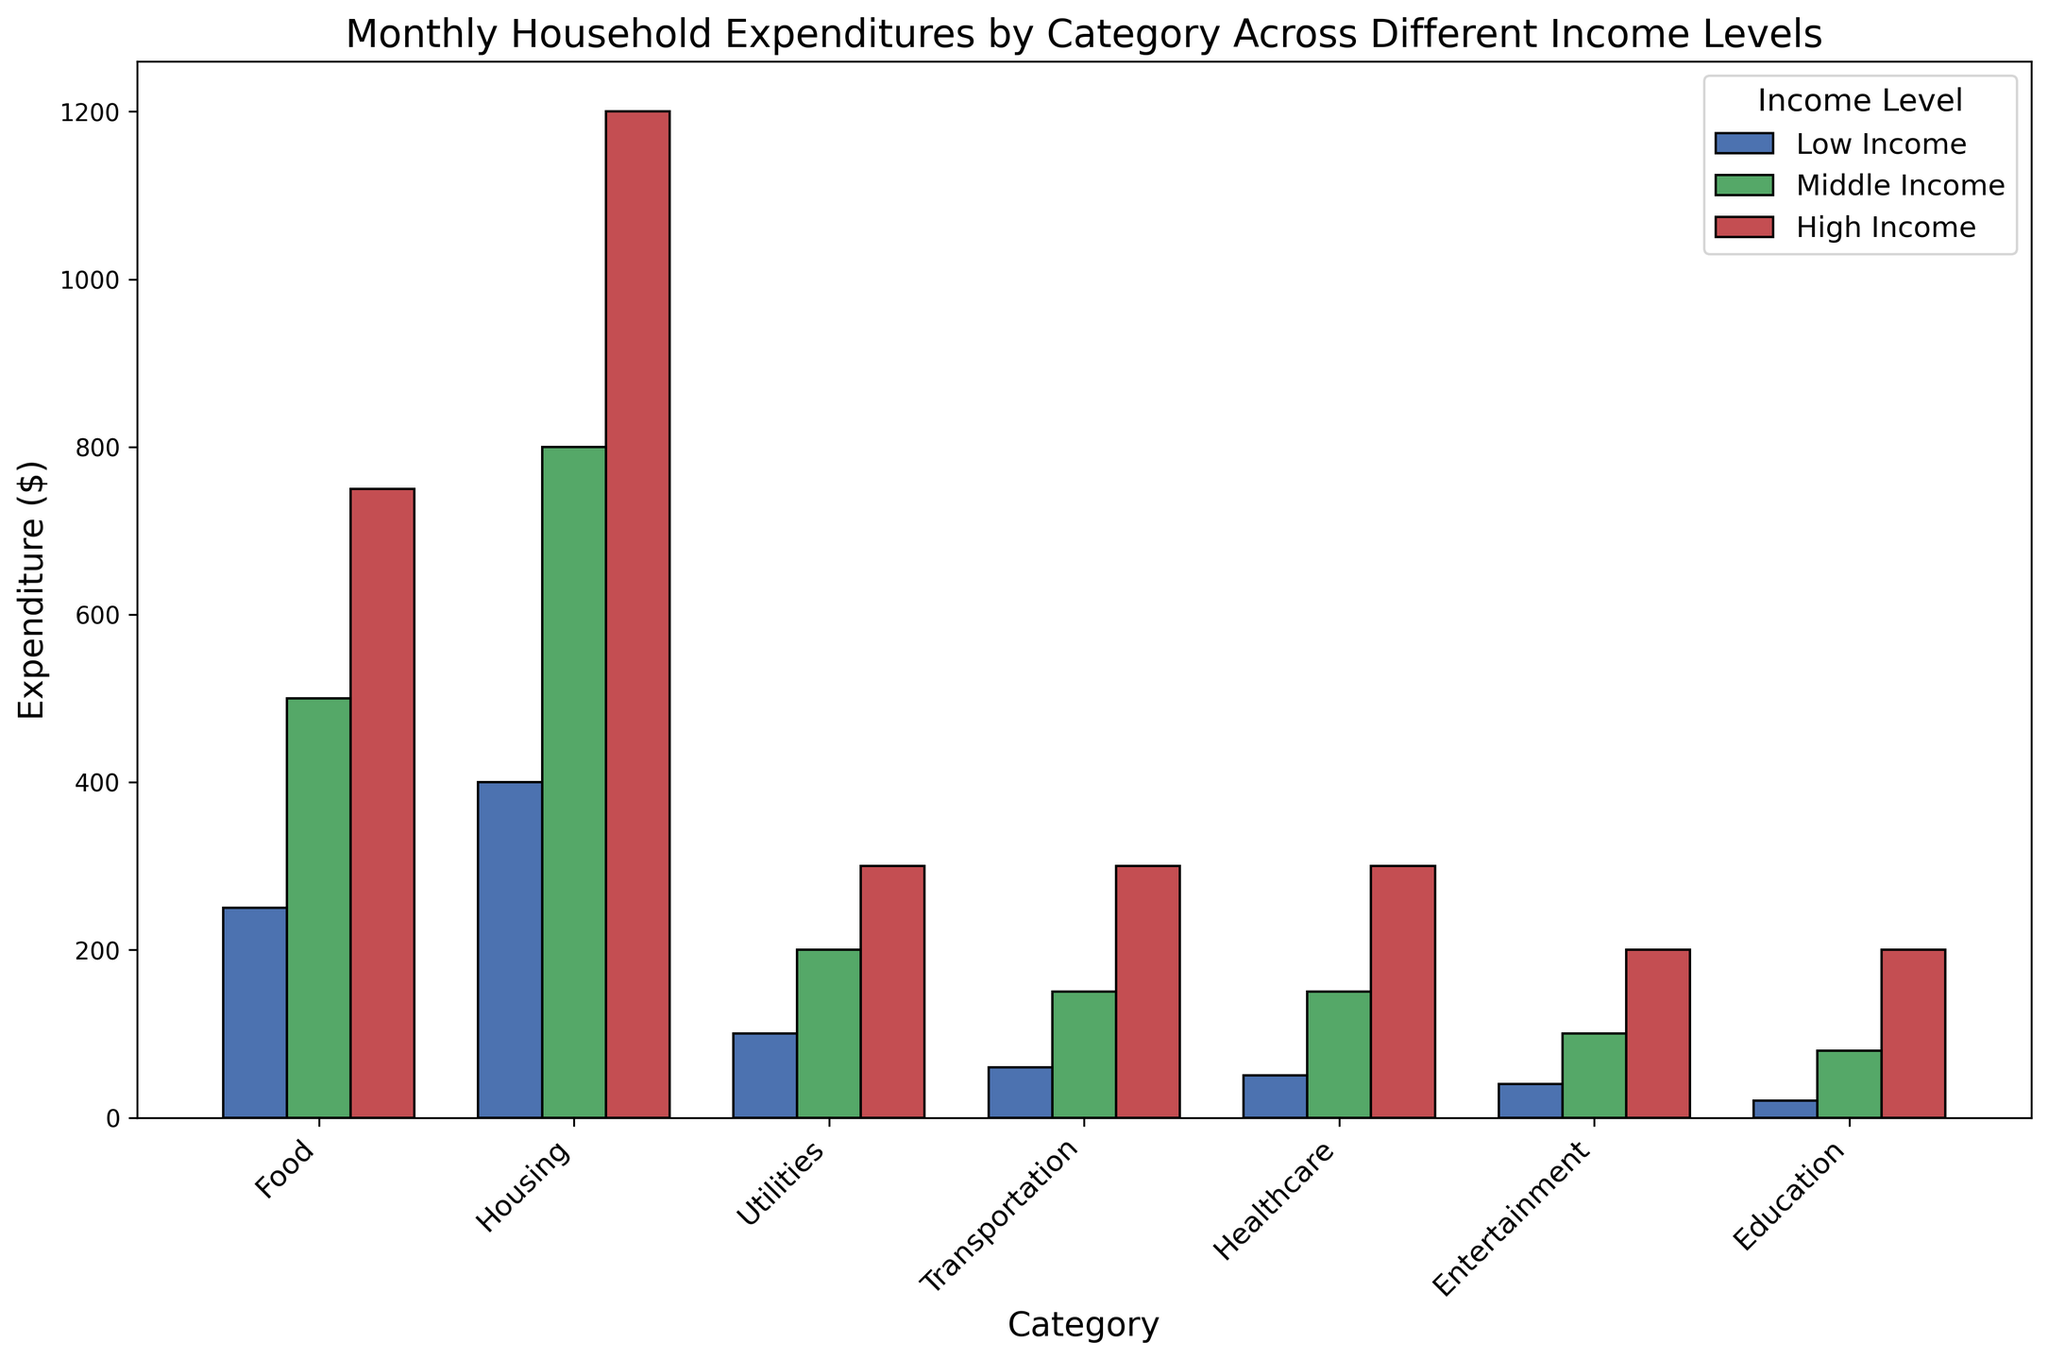What is the expenditure on Healthcare for High Income compared to Low Income? To compare the expenditure on Healthcare, find the values for High Income and Low Income in the Healthcare category. High Income expenditure on Healthcare is $300. Low Income expenditure on Healthcare is $50. Thus, the expenditure on Healthcare for High Income is $300, which is $250 more than Low Income ($50).
Answer: $250 more Which income level has the highest total expenditure on Housing? To determine the highest total expenditure on Housing, compare the values for each income level in the Housing category. Low Income has $400, Middle Income has $800, and High Income has $1200. Therefore, High Income has the highest total expenditure on Housing with $1200.
Answer: High Income What is the difference in expenditure on Transportation between Middle Income and Low Income? Compare the expenditure on Transportation for Middle Income ($150) and Low Income ($60). Calculating the difference: $150 - $60 = $90. Thus, the difference in expenditure on Transportation between Middle Income and Low Income is $90.
Answer: $90 What is the highest expenditure category for Low Income, and how much is it? Look at all expenditure categories for Low Income and identify the highest value. The values are: Food ($250), Housing ($400), Utilities ($100), Transportation ($60), Healthcare ($50), Entertainment ($40), Education ($20). The highest expenditure is Housing with $400.
Answer: Housing, $400 What is the total monthly expenditure for Middle Income? Sum all expenditure values for Middle Income across all categories: Food ($500) + Housing ($800) + Utilities ($200) + Transportation ($150) + Healthcare ($150) + Entertainment ($100) + Education ($80) = $1980. Therefore, the total monthly expenditure for Middle Income is $1980.
Answer: $1980 Which income level spends the most on Education, and by how much compared to the other levels? Compare the expenditure on Education for all income levels: High Income ($200), Middle Income ($80), Low Income ($20). High Income spends the most on Education with $200. Compared to Middle Income, the difference is $200 - $80 = $120. Compared to Low Income, the difference is $200 - $20 = $180.
Answer: High Income, $120 more than Middle, $180 more than Low 